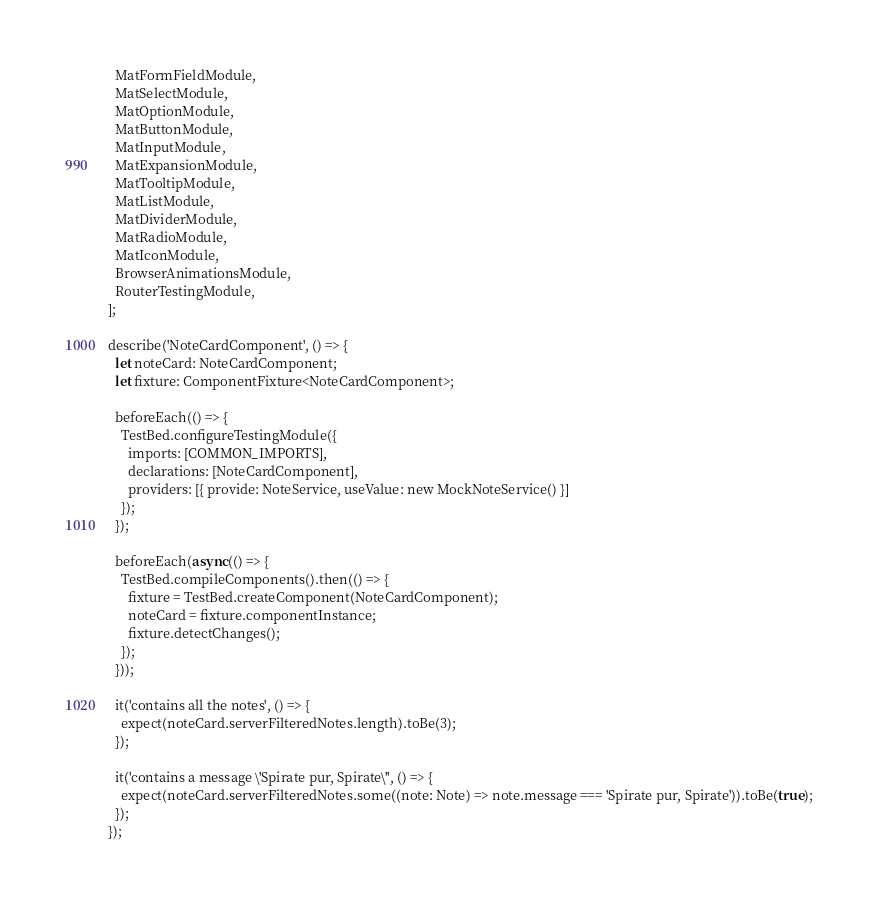Convert code to text. <code><loc_0><loc_0><loc_500><loc_500><_TypeScript_>  MatFormFieldModule,
  MatSelectModule,
  MatOptionModule,
  MatButtonModule,
  MatInputModule,
  MatExpansionModule,
  MatTooltipModule,
  MatListModule,
  MatDividerModule,
  MatRadioModule,
  MatIconModule,
  BrowserAnimationsModule,
  RouterTestingModule,
];

describe('NoteCardComponent', () => {
  let noteCard: NoteCardComponent;
  let fixture: ComponentFixture<NoteCardComponent>;

  beforeEach(() => {
    TestBed.configureTestingModule({
      imports: [COMMON_IMPORTS],
      declarations: [NoteCardComponent],
      providers: [{ provide: NoteService, useValue: new MockNoteService() }]
    });
  });

  beforeEach(async(() => {
    TestBed.compileComponents().then(() => {
      fixture = TestBed.createComponent(NoteCardComponent);
      noteCard = fixture.componentInstance;
      fixture.detectChanges();
    });
  }));

  it('contains all the notes', () => {
    expect(noteCard.serverFilteredNotes.length).toBe(3);
  });

  it('contains a message \'Spirate pur, Spirate\'', () => {
    expect(noteCard.serverFilteredNotes.some((note: Note) => note.message === 'Spirate pur, Spirate')).toBe(true);
  });
});
</code> 